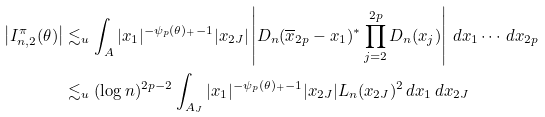Convert formula to latex. <formula><loc_0><loc_0><loc_500><loc_500>\left | I _ { n , 2 } ^ { \pi } ( \theta ) \right | & \lesssim _ { u } \int _ { A } | x _ { 1 } | ^ { - \psi _ { p } ( \theta ) _ { + } - 1 } | x _ { 2 J } | \left | D _ { n } ( \overline { x } _ { 2 p } - x _ { 1 } ) ^ { \ast } \prod _ { j = 2 } ^ { 2 p } D _ { n } ( x _ { j } ) \right | \, d x _ { 1 } \cdots \, d x _ { 2 p } \\ & \lesssim _ { u } ( \log { n } ) ^ { 2 p - 2 } \int _ { A _ { J } } | x _ { 1 } | ^ { - \psi _ { p } ( \theta ) _ { + } - 1 } | x _ { 2 J } | L _ { n } ( x _ { 2 J } ) ^ { 2 } \, d x _ { 1 } \, d x _ { 2 J }</formula> 